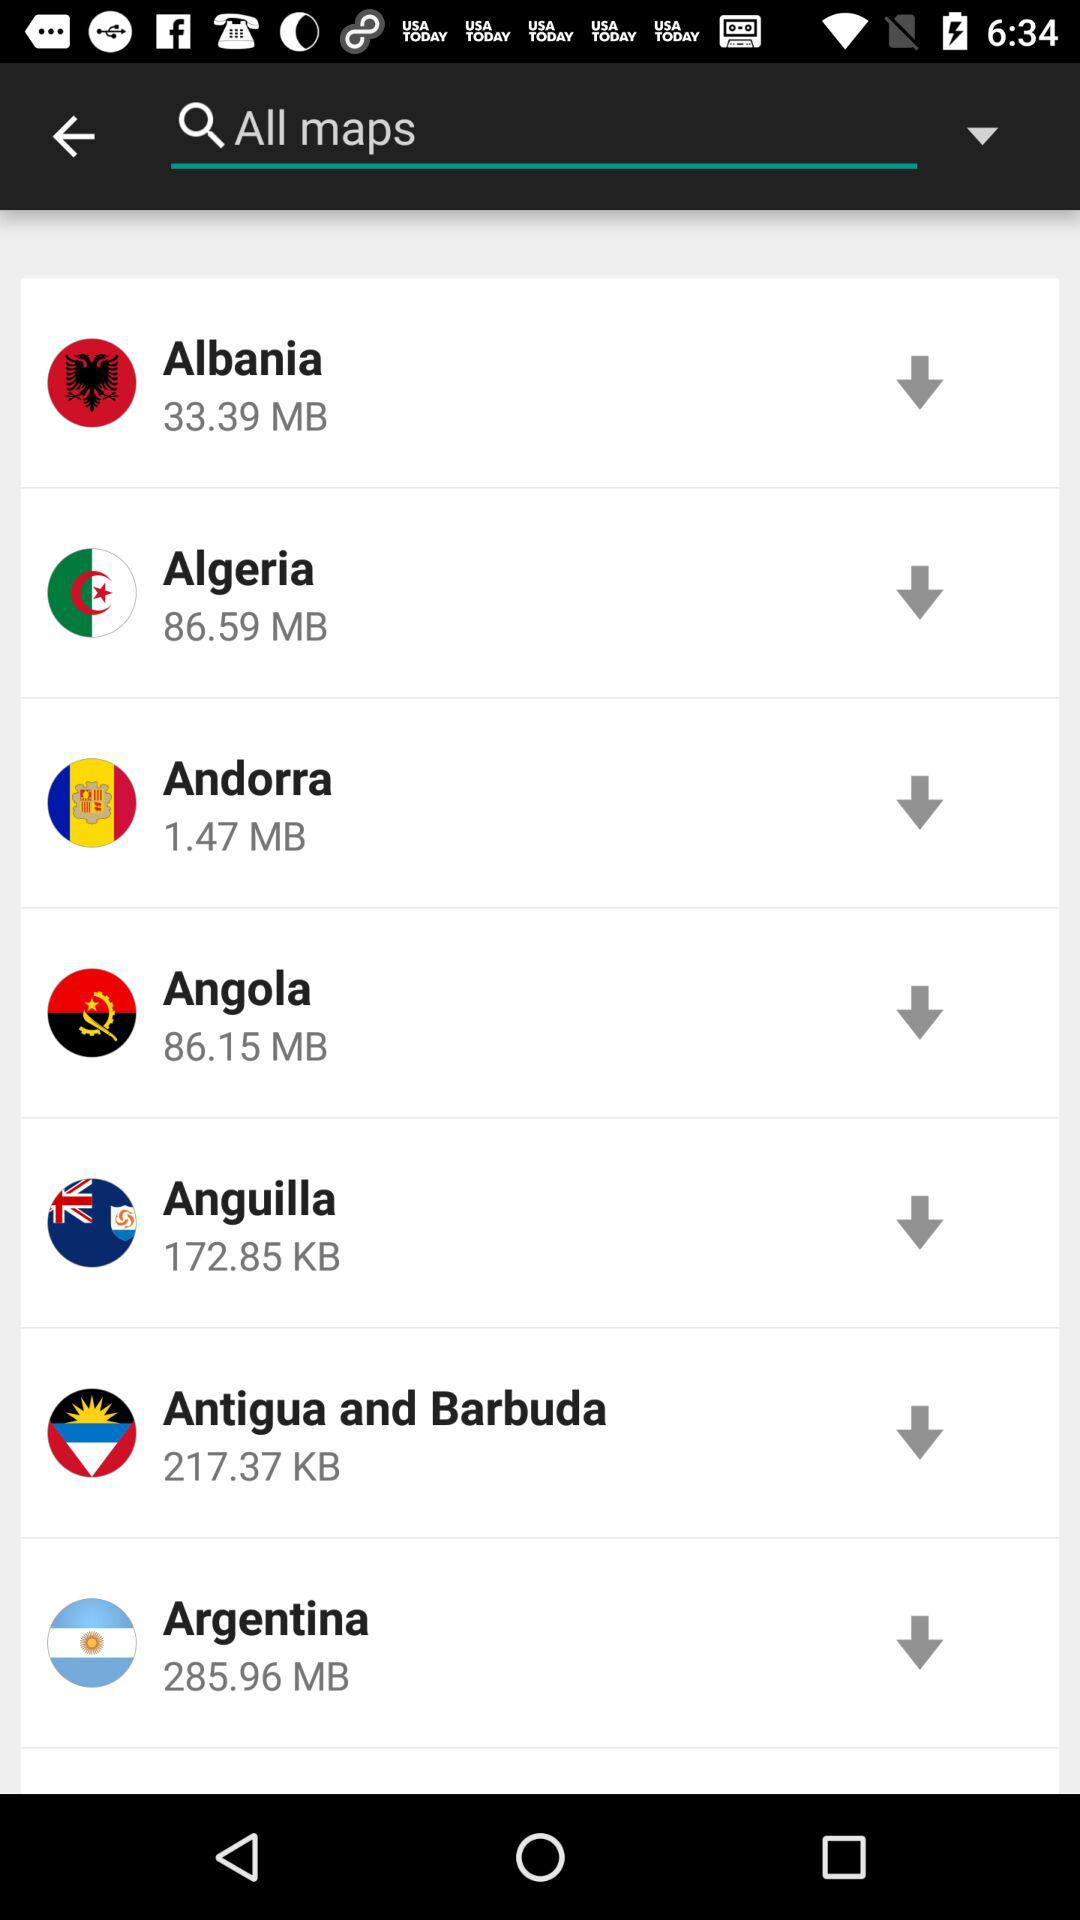What is the size of the "Andorra" file? The size of the "Andorra" file is 1.47 MB. 